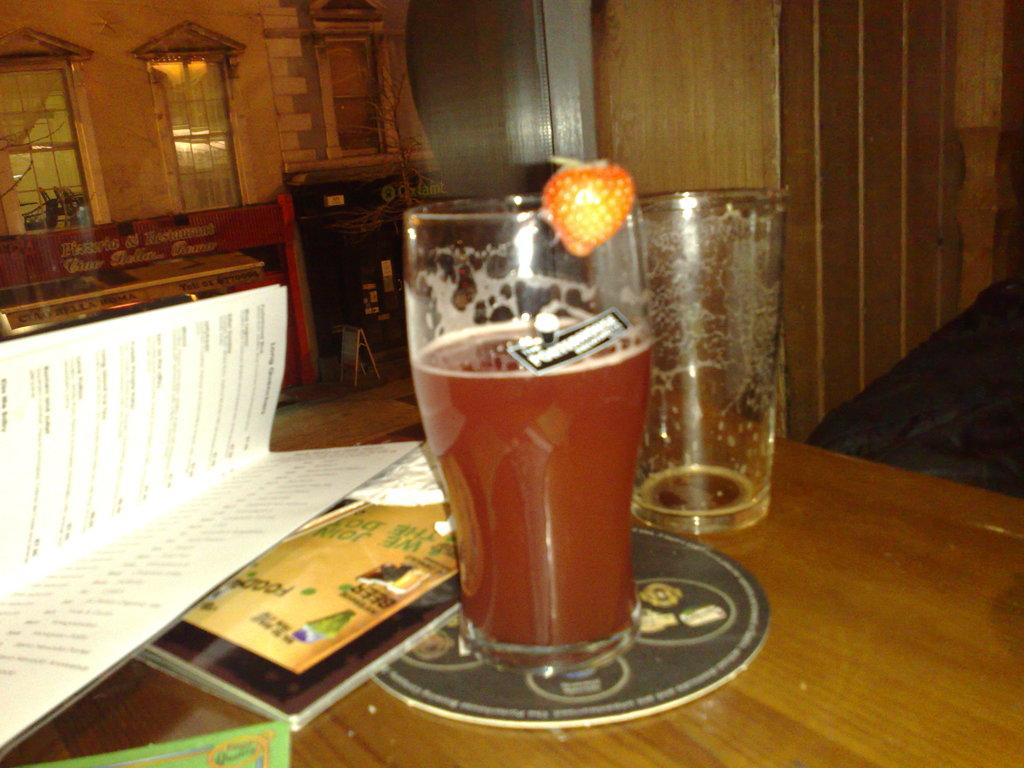What is in the glass that is visible in the image? There is a glass with liquid in the image. Are there any other glasses in the image? Yes, there is an empty glass on the table. What else can be seen in the image besides the glasses? There are papers and objects on the table. What type of wine is being served in the glass? There is no wine present in the image; it only shows a glass with liquid and an empty glass. Can you see a hen in the image? No, there is no hen present in the image. 